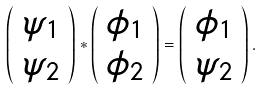<formula> <loc_0><loc_0><loc_500><loc_500>\left ( \begin{array} { c } \psi _ { 1 } \\ \psi _ { 2 } \end{array} \right ) * \left ( \begin{array} { c } \phi _ { 1 } \\ \phi _ { 2 } \end{array} \right ) = \left ( \begin{array} { c } \phi _ { 1 } \\ \psi _ { 2 } \end{array} \right ) .</formula> 